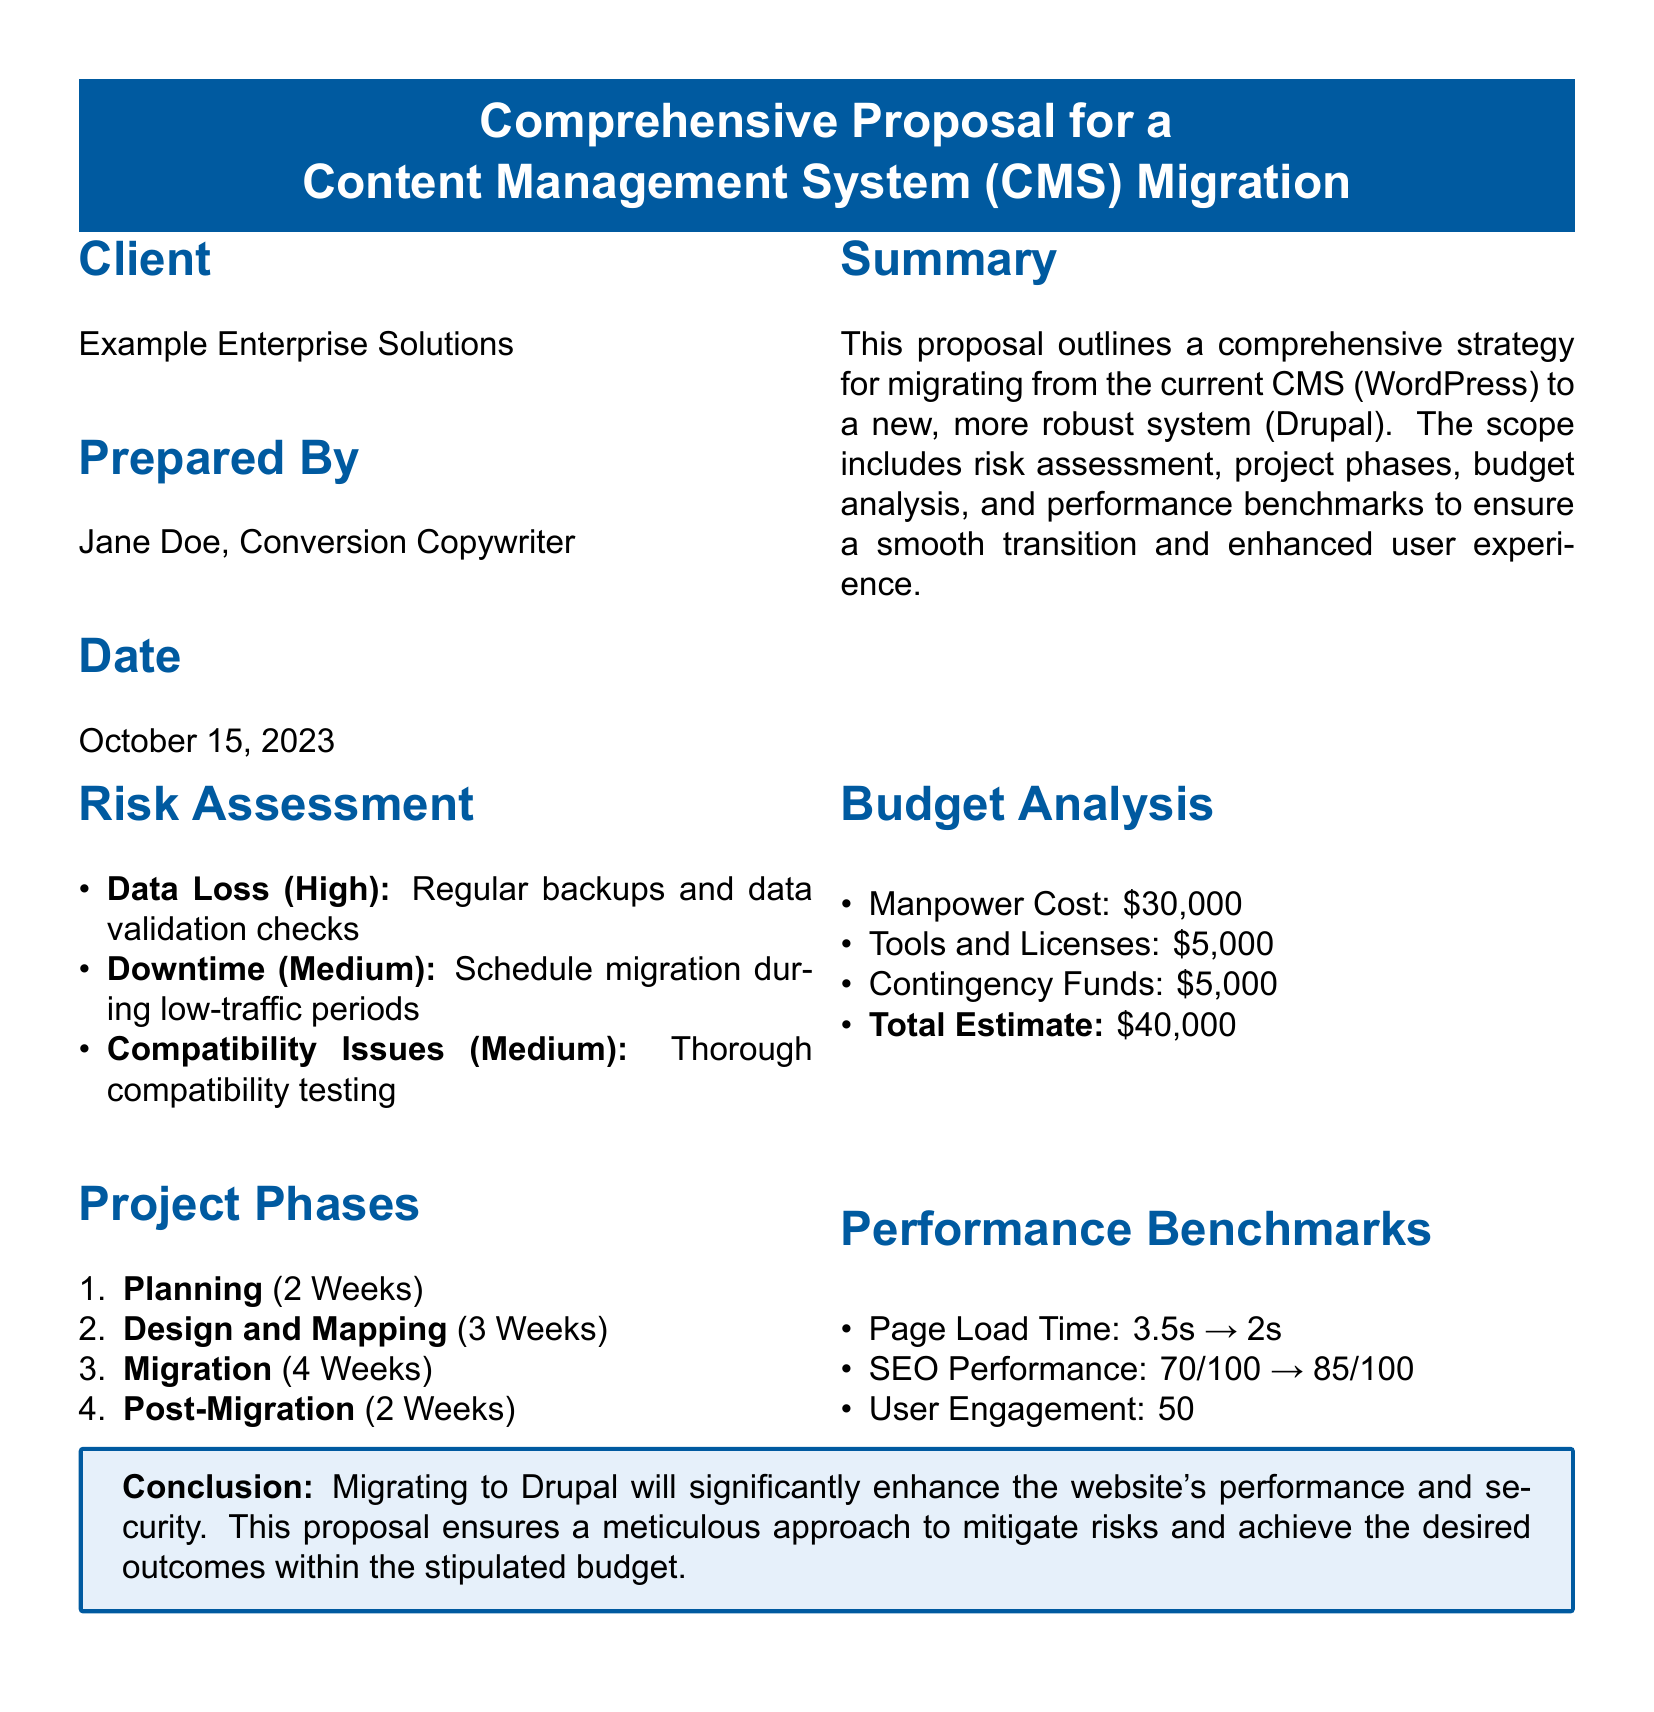What is the name of the client? The client is mentioned at the beginning of the document under the "Client" section, which states "Example Enterprise Solutions."
Answer: Example Enterprise Solutions Who prepared the proposal? The "Prepared By" section of the document identifies the individual as "Jane Doe, Conversion Copywriter."
Answer: Jane Doe, Conversion Copywriter What is the total budget estimate? The total budget estimate is found in the "Budget Analysis" section and is clearly stated as "$40,000."
Answer: $40,000 What is the expected SEO Performance after migration? The expected SEO Performance is described in the "Performance Benchmarks" section, which notes a change from "70/100" to "85/100."
Answer: 85/100 How long is the migration phase scheduled to take? The duration for the migration phase is mentioned in the "Project Phases" section as "4 Weeks."
Answer: 4 Weeks What is the risk level of data loss according to the assessment? The "Risk Assessment" section categorizes data loss as "High."
Answer: High During which period should the migration be scheduled to minimize downtime? The document suggests scheduling the migration during "low-traffic periods" to mitigate risk.
Answer: Low-traffic periods What is the current page load time mentioned in the benchmarks? The "Performance Benchmarks" section indicates the current page load time as "3.5s."
Answer: 3.5s How long will the planning phase last? The "Project Phases" section states that the planning phase will take "2 Weeks."
Answer: 2 Weeks 